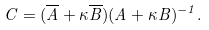<formula> <loc_0><loc_0><loc_500><loc_500>C = ( \overline { A } + \kappa \overline { B } ) ( A + \kappa B ) ^ { - 1 } .</formula> 